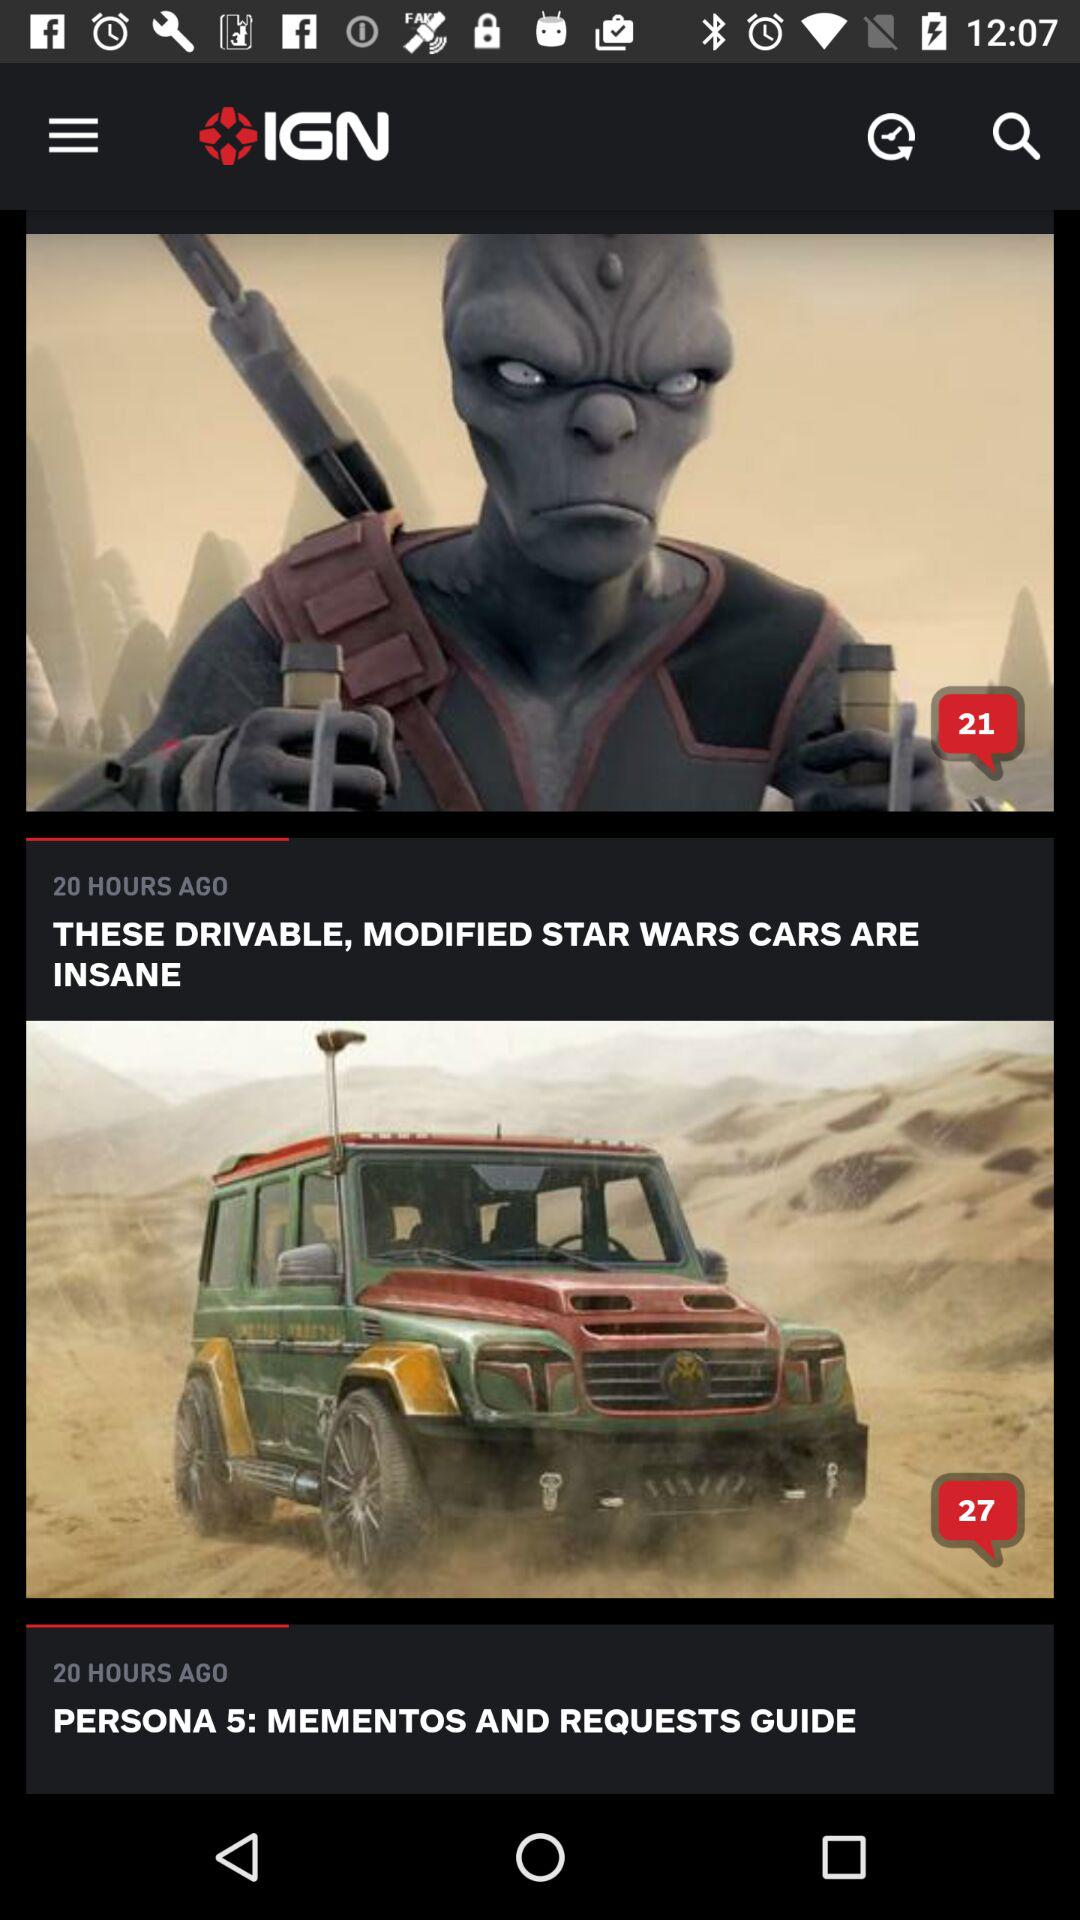What is the number of comments on "THESE DRIVABLE, MODIFIED STAR WARS CARS ARE INSANE"? The number of comments is 21. 